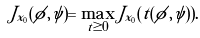Convert formula to latex. <formula><loc_0><loc_0><loc_500><loc_500>J _ { x _ { 0 } } ( \phi , \psi ) = \max _ { t \geq 0 } J _ { x _ { 0 } } ( t ( \phi , \psi ) ) .</formula> 